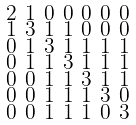<formula> <loc_0><loc_0><loc_500><loc_500>\begin{smallmatrix} 2 & 1 & 0 & 0 & 0 & 0 & 0 \\ 1 & 3 & 1 & 1 & 0 & 0 & 0 \\ 0 & 1 & 3 & 1 & 1 & 1 & 1 \\ 0 & 1 & 1 & 3 & 1 & 1 & 1 \\ 0 & 0 & 1 & 1 & 3 & 1 & 1 \\ 0 & 0 & 1 & 1 & 1 & 3 & 0 \\ 0 & 0 & 1 & 1 & 1 & 0 & 3 \end{smallmatrix}</formula> 